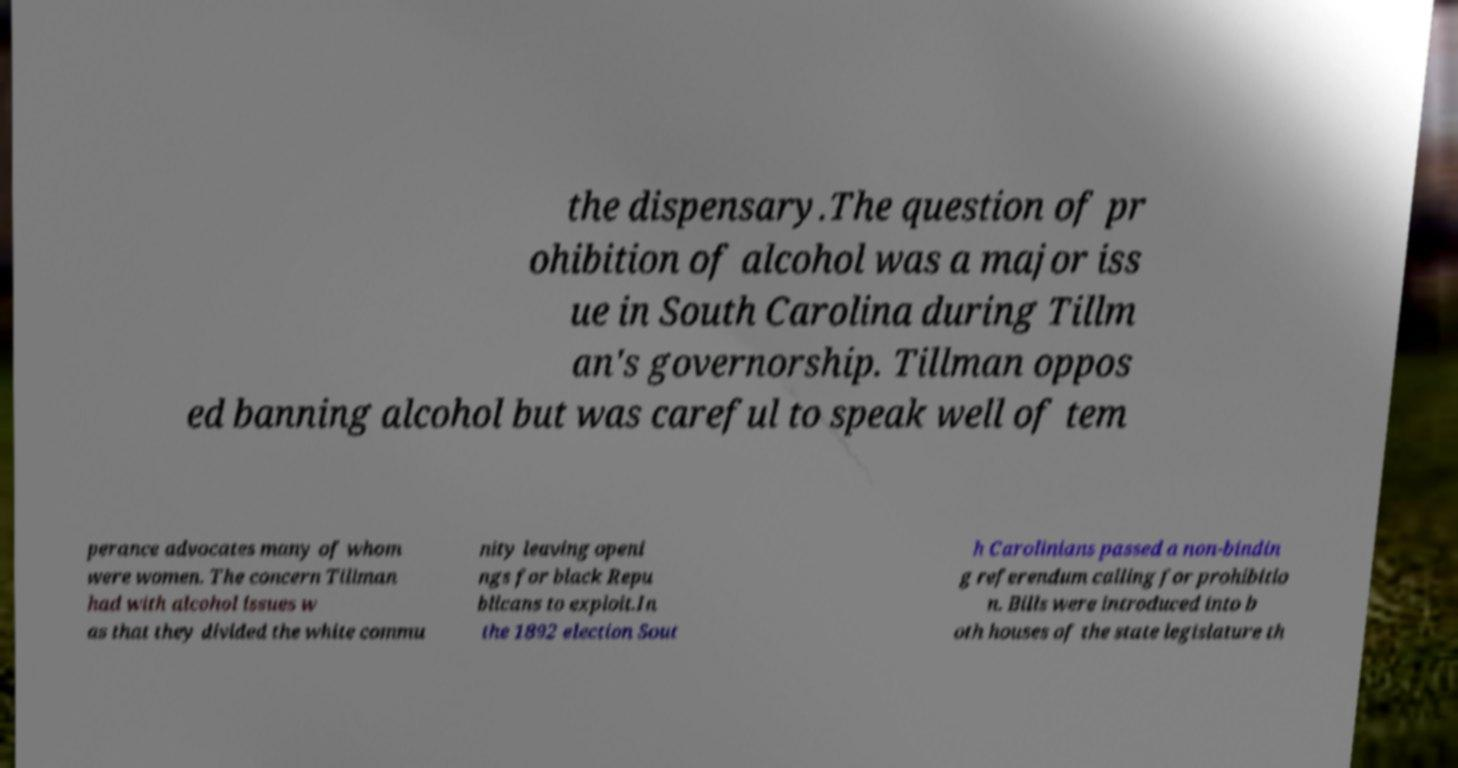Can you read and provide the text displayed in the image?This photo seems to have some interesting text. Can you extract and type it out for me? the dispensary.The question of pr ohibition of alcohol was a major iss ue in South Carolina during Tillm an's governorship. Tillman oppos ed banning alcohol but was careful to speak well of tem perance advocates many of whom were women. The concern Tillman had with alcohol issues w as that they divided the white commu nity leaving openi ngs for black Repu blicans to exploit.In the 1892 election Sout h Carolinians passed a non-bindin g referendum calling for prohibitio n. Bills were introduced into b oth houses of the state legislature th 